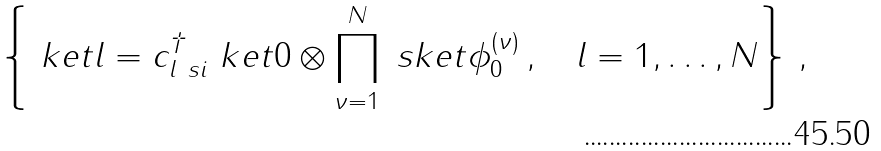<formula> <loc_0><loc_0><loc_500><loc_500>\left \{ \ k e t { l } = c ^ { \dag } _ { l \ s i } \ k e t { 0 } \otimes \prod _ { \nu = 1 } ^ { N } \ s k e t { \phi _ { 0 } ^ { ( \nu ) } } \, , \quad l = 1 , \dots , N \right \} \, ,</formula> 